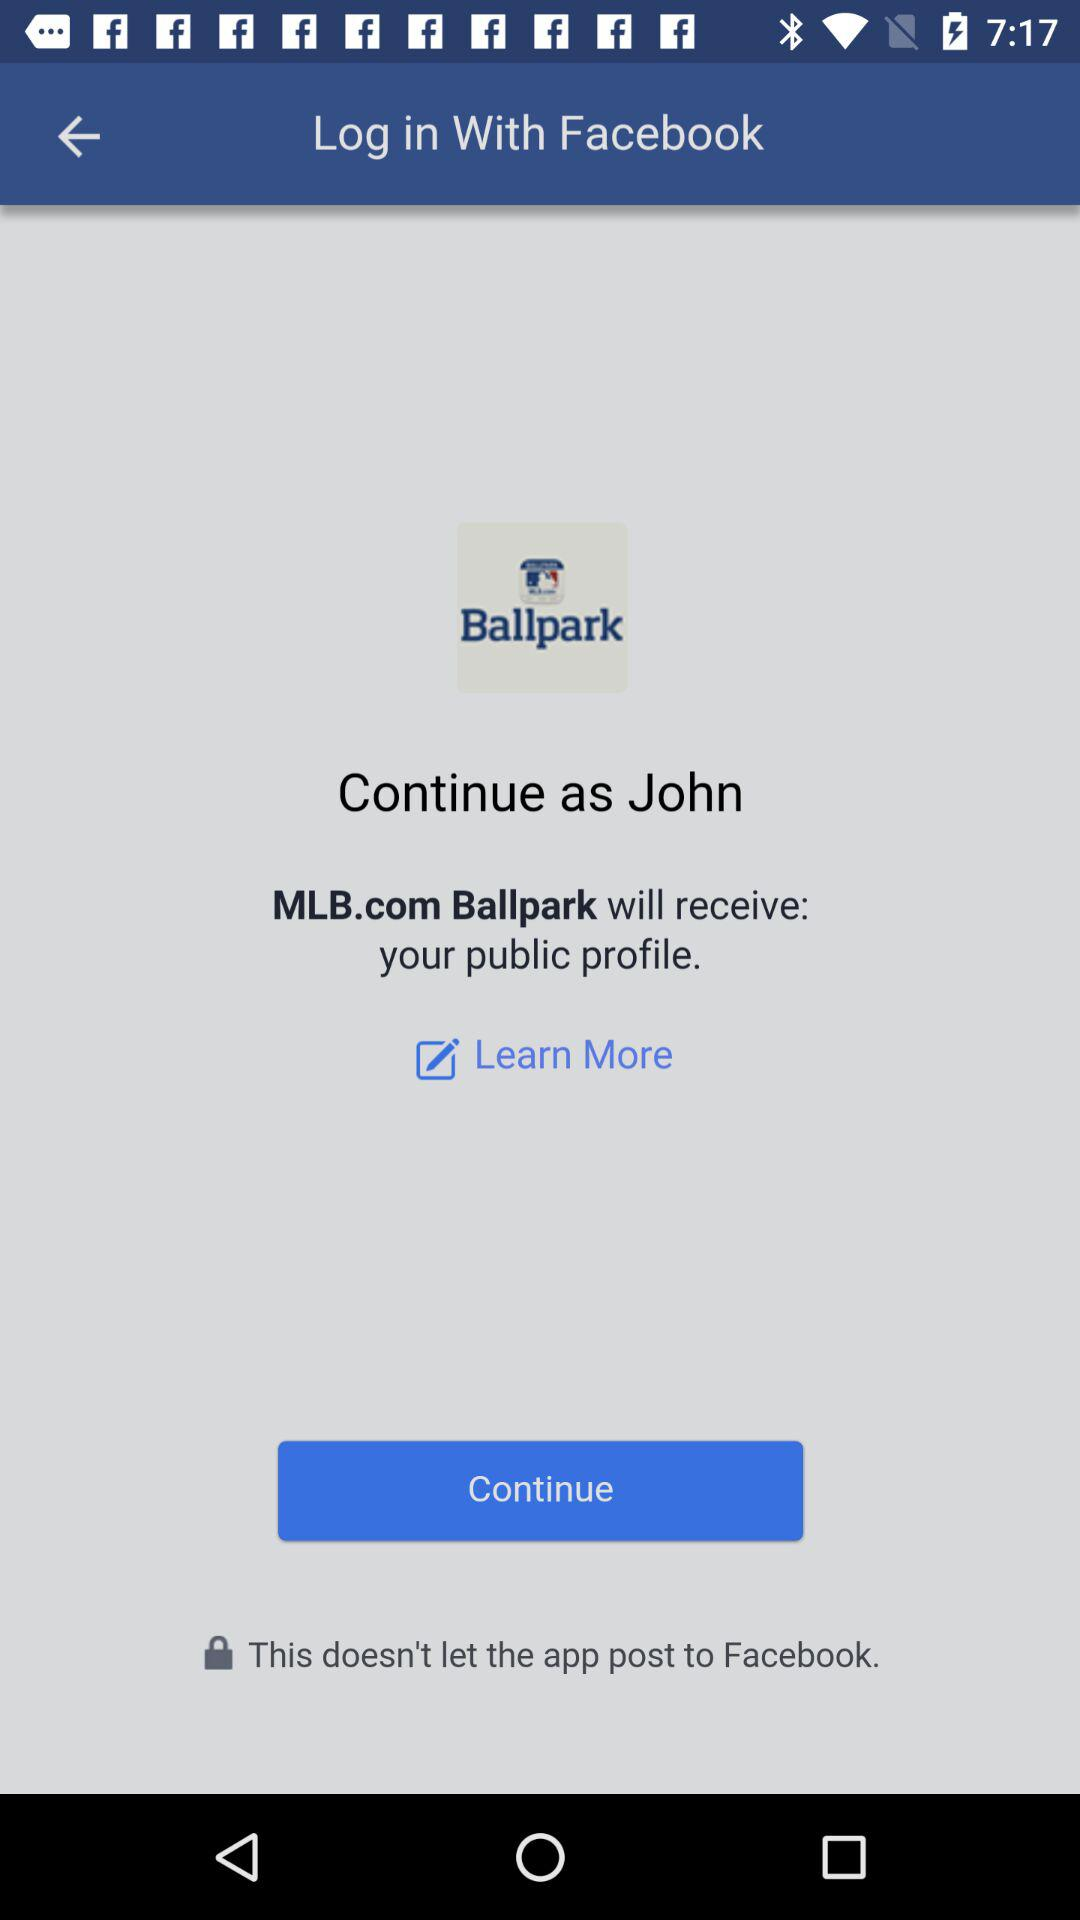What application is asking for permission? The application is MLB.com Ballpark. 